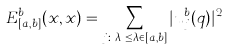<formula> <loc_0><loc_0><loc_500><loc_500>E _ { [ a , b ] } ^ { b } ( x , x ) = \sum _ { j \colon \lambda _ { j } \leq \lambda \in [ a , b ] } | u _ { j } ^ { b } ( q ) | ^ { 2 }</formula> 